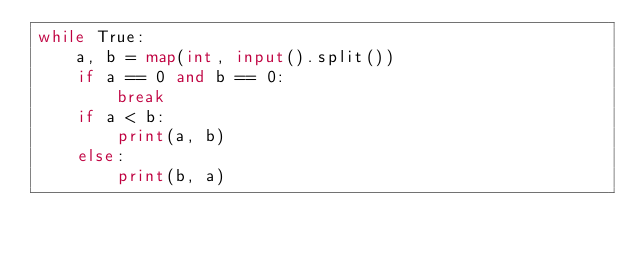<code> <loc_0><loc_0><loc_500><loc_500><_Python_>while True:
    a, b = map(int, input().split())
    if a == 0 and b == 0:
        break
    if a < b:
        print(a, b)
    else:
        print(b, a)
</code> 